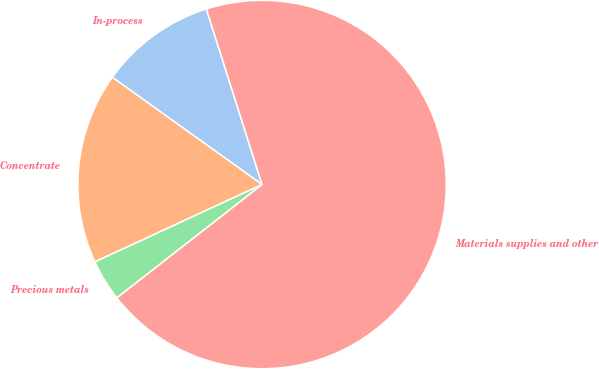<chart> <loc_0><loc_0><loc_500><loc_500><pie_chart><fcel>In-process<fcel>Concentrate<fcel>Precious metals<fcel>Materials supplies and other<nl><fcel>10.22%<fcel>16.79%<fcel>3.65%<fcel>69.34%<nl></chart> 